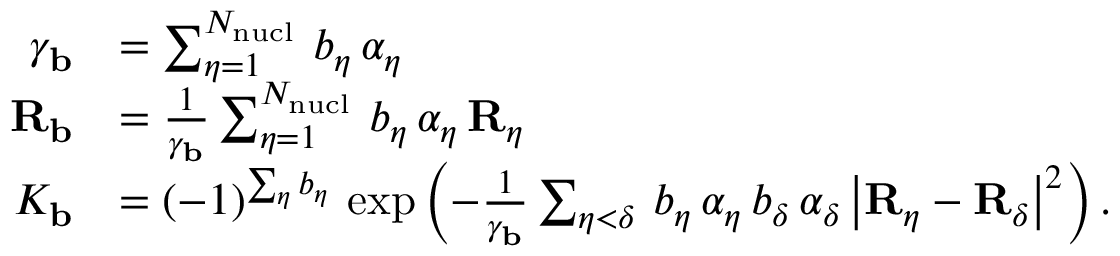Convert formula to latex. <formula><loc_0><loc_0><loc_500><loc_500>\begin{array} { r l } { \gamma _ { b } } & { = \sum _ { \eta = 1 } ^ { N _ { n u c l } } \, b _ { \eta } \, \alpha _ { \eta } } \\ { { R _ { b } } } & { = \frac { 1 } { \gamma _ { b } } \sum _ { \eta = 1 } ^ { N _ { n u c l } } \, b _ { \eta } \, \alpha _ { \eta } \, { R _ { \eta } } } \\ { K _ { b } } & { = ( - 1 ) ^ { \sum _ { \eta } b _ { \eta } } \, \exp \left ( - \frac { 1 } { \gamma _ { b } } \sum _ { \eta < \delta } \, b _ { \eta } \, \alpha _ { \eta } \, b _ { \delta } \, \alpha _ { \delta } \, \left | { R _ { \eta } } - { R _ { \delta } } \right | ^ { 2 } \right ) . } \end{array}</formula> 